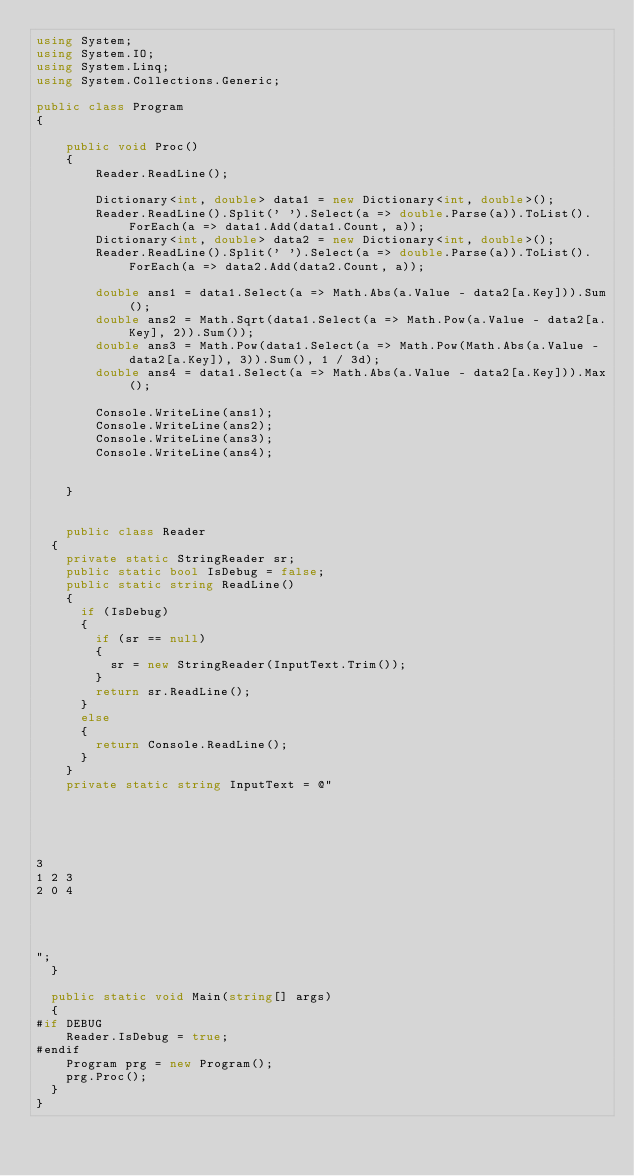Convert code to text. <code><loc_0><loc_0><loc_500><loc_500><_C#_>using System;
using System.IO;
using System.Linq;
using System.Collections.Generic;

public class Program
{

    public void Proc()
    {
        Reader.ReadLine();

        Dictionary<int, double> data1 = new Dictionary<int, double>();
        Reader.ReadLine().Split(' ').Select(a => double.Parse(a)).ToList().ForEach(a => data1.Add(data1.Count, a));
        Dictionary<int, double> data2 = new Dictionary<int, double>();
        Reader.ReadLine().Split(' ').Select(a => double.Parse(a)).ToList().ForEach(a => data2.Add(data2.Count, a));

        double ans1 = data1.Select(a => Math.Abs(a.Value - data2[a.Key])).Sum();
        double ans2 = Math.Sqrt(data1.Select(a => Math.Pow(a.Value - data2[a.Key], 2)).Sum());
        double ans3 = Math.Pow(data1.Select(a => Math.Pow(Math.Abs(a.Value - data2[a.Key]), 3)).Sum(), 1 / 3d);
        double ans4 = data1.Select(a => Math.Abs(a.Value - data2[a.Key])).Max();

        Console.WriteLine(ans1);
        Console.WriteLine(ans2);
        Console.WriteLine(ans3);
        Console.WriteLine(ans4);


    }


    public class Reader
	{
		private static StringReader sr;
		public static bool IsDebug = false;
		public static string ReadLine()
		{
			if (IsDebug)
			{
				if (sr == null)
				{
					sr = new StringReader(InputText.Trim());
				}
				return sr.ReadLine();
			}
			else
			{
				return Console.ReadLine();
			}
		}
		private static string InputText = @"





3
1 2 3
2 0 4




";
	}

	public static void Main(string[] args)
	{
#if DEBUG
		Reader.IsDebug = true;
#endif
		Program prg = new Program();
		prg.Proc();
	}
}</code> 